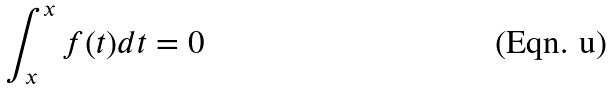Convert formula to latex. <formula><loc_0><loc_0><loc_500><loc_500>\int _ { x } ^ { x } f ( t ) d t = 0</formula> 